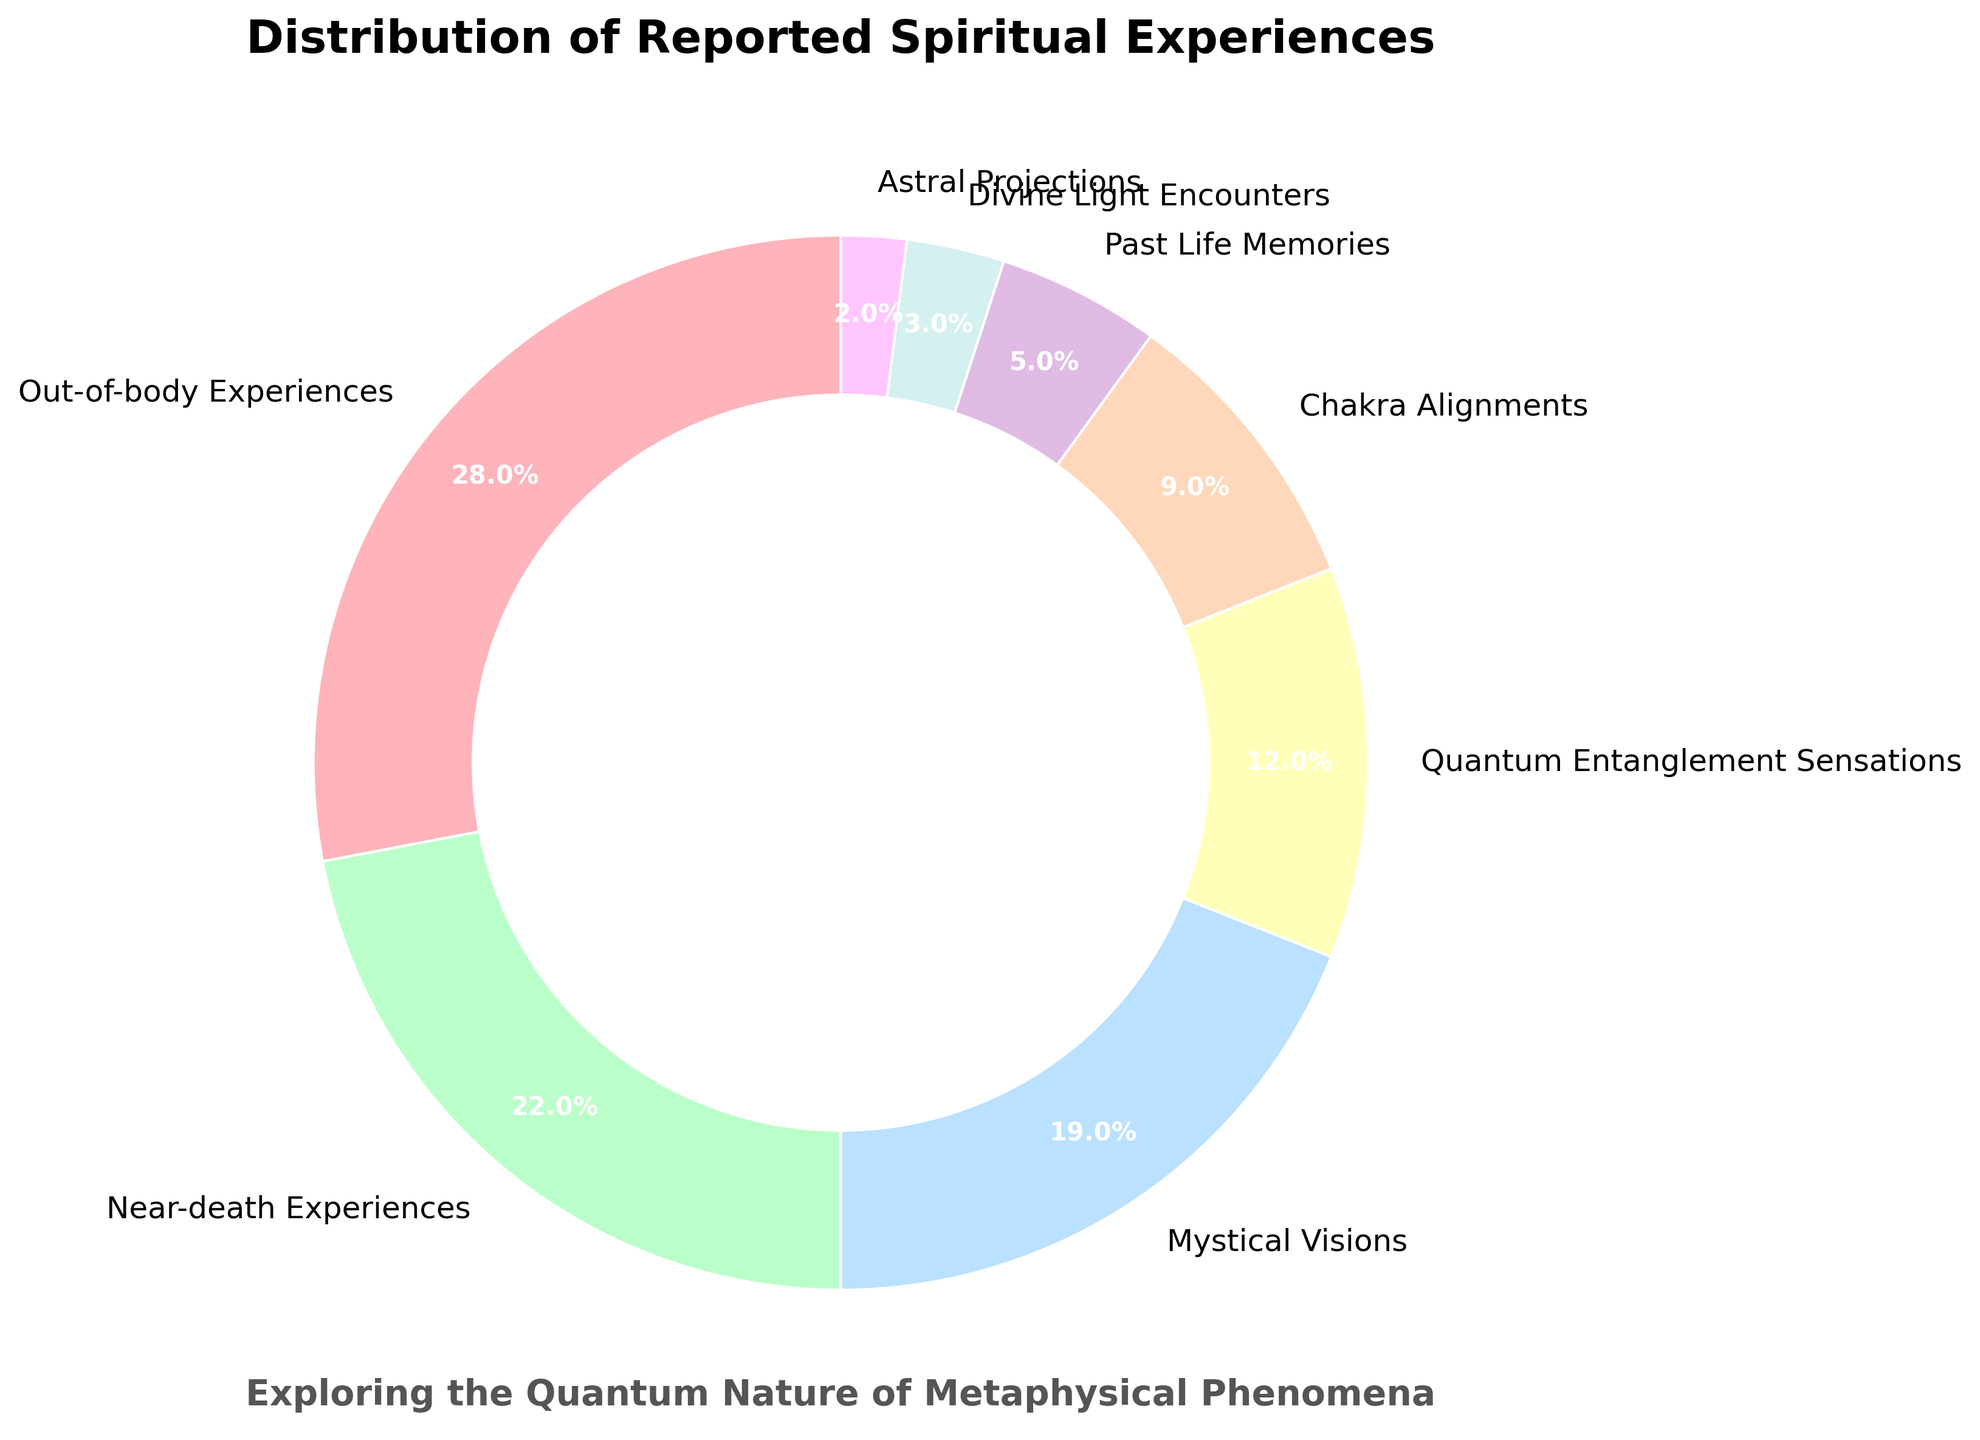Which type of spiritual experience has the highest reported percentage? Identify the largest segment in the pie chart, which represents the most reported spiritual experience.
Answer: Out-of-body Experiences Which two types of experiences have a combined percentage of more than 40%? Add the percentages of each experience type and identify which combination exceeds 40%. Out-of-body Experiences have 28% and Near-death Experiences have 22%, which together is 50%.
Answer: Out-of-body Experiences and Near-death Experiences What is the visual difference between 'Mystical Visions' and 'Past Life Memories'? Compare the pie slices corresponding to these experiences. 'Mystical Visions' has a noticeably larger slice compared to 'Past Life Memories'. 'Mystical Visions' has 19%, whereas 'Past Life Memories' has only 5%.
Answer: Mystical Visions has a much larger section compared to Past Life Memories How much more reported are 'Chakra Alignments' compared to 'Astral Projections'? Subtract the percentage of Astral Projections (2%) from Chakra Alignments (9%). 9% - 2% = 7%.
Answer: 7% Which types of experiences have a reported percentage less than 10%? Identify the segments in the pie chart whose percentages are below 10%. These are Chakra Alignments (9%), Past Life Memories (5%), Divine Light Encounters (3%), and Astral Projections (2%).
Answer: Chakra Alignments, Past Life Memories, Divine Light Encounters, and Astral Projections What percentage of experiences are related to "quantum entanglement sensations"? Locate the segment labeled "Quantum Entanglement Sensations" and note its percentage.
Answer: 12% Which experience types collectively form exactly 32% of the total? Add the percentages of different experience types to find a combination that totals 32%. Quantum Entanglement Sensations (12%) plus Chakra Alignments (9%) plus Past Life Memories (5%) plus Divine Light Encounters (3%) plus Astral Projections (2%) equal 31%, which is not possible; thus, the straightforward sets like Near-death Experiences (22%) plus Mystical Visions (19%) equal 41%, thus we need to go through until the exact criteria can be obtained for the smaller sets, if not possible then single set could be standing alone.
Answer: Not possible in combined groups 